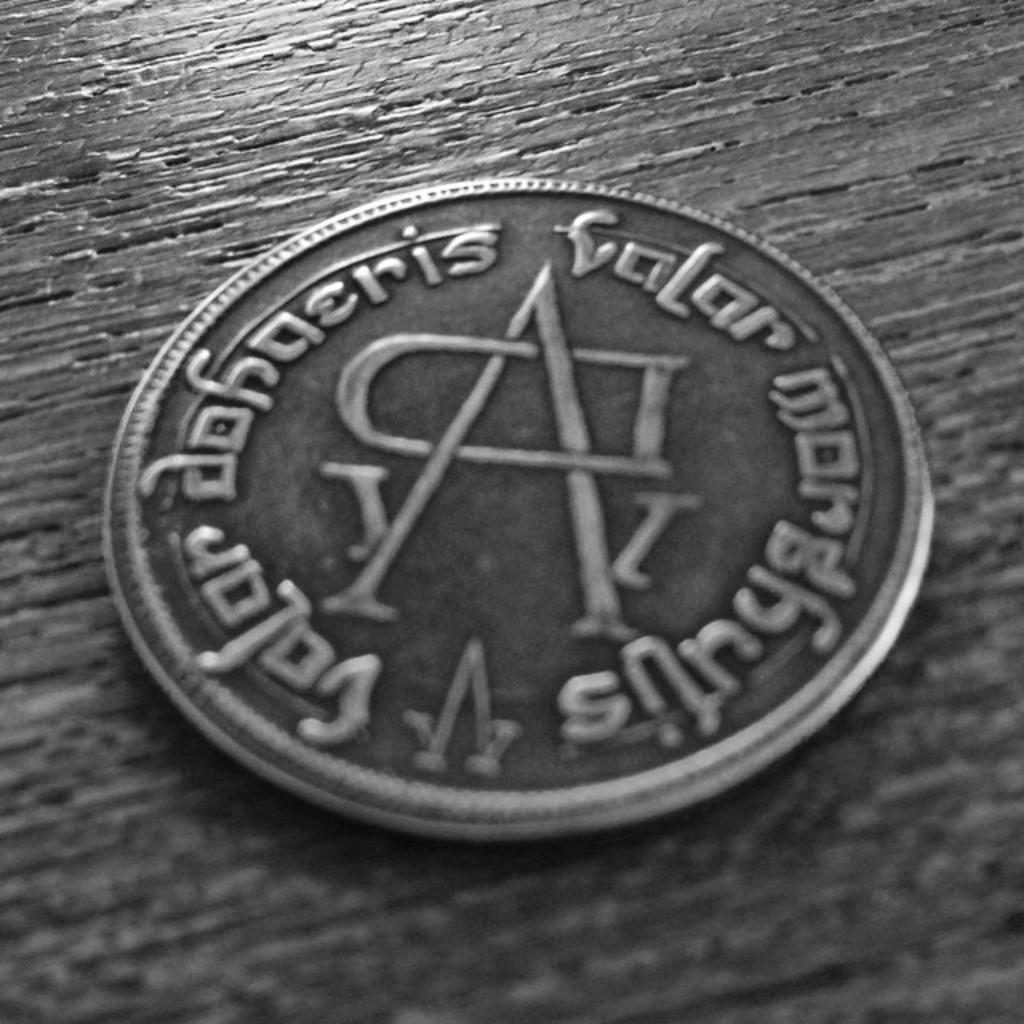<image>
Relay a brief, clear account of the picture shown. A coin with the  word valar engraved on it along with a large letter A in the middle of the coin. 